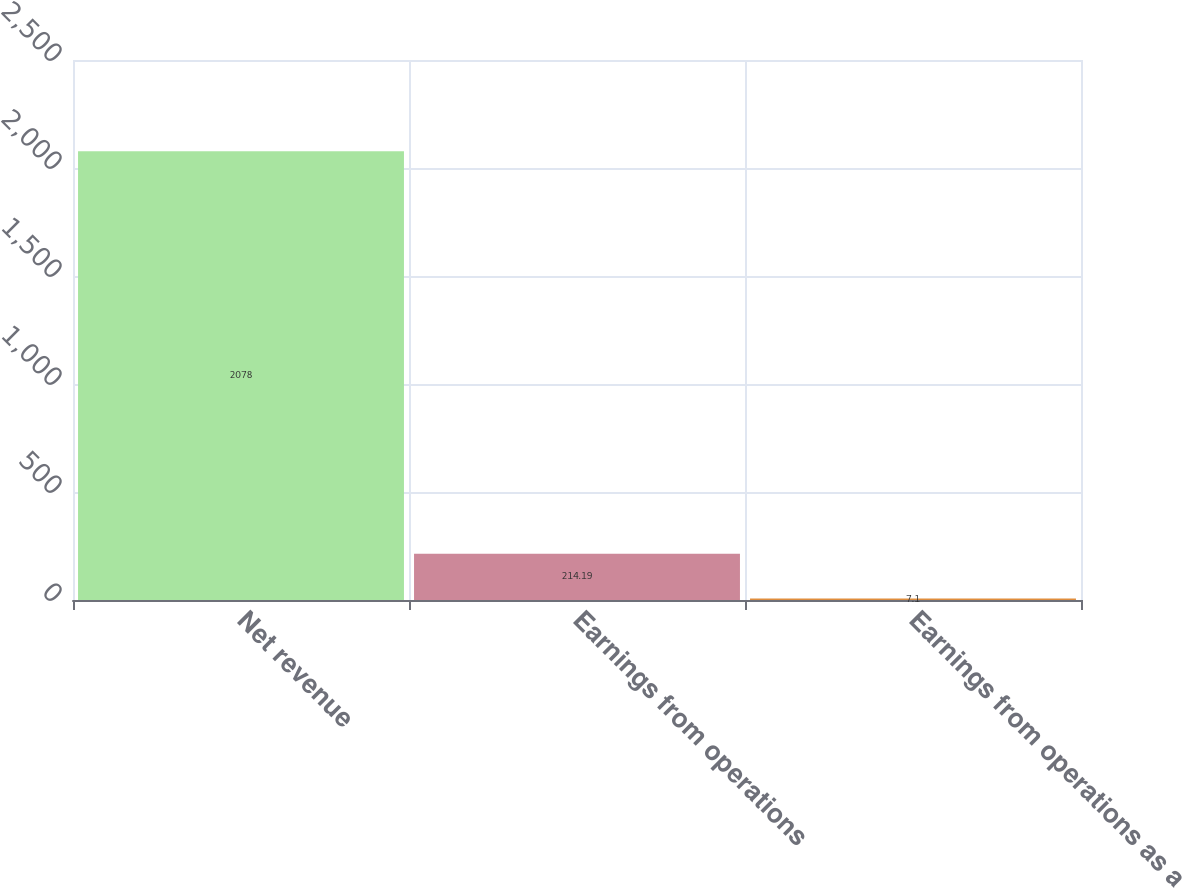<chart> <loc_0><loc_0><loc_500><loc_500><bar_chart><fcel>Net revenue<fcel>Earnings from operations<fcel>Earnings from operations as a<nl><fcel>2078<fcel>214.19<fcel>7.1<nl></chart> 